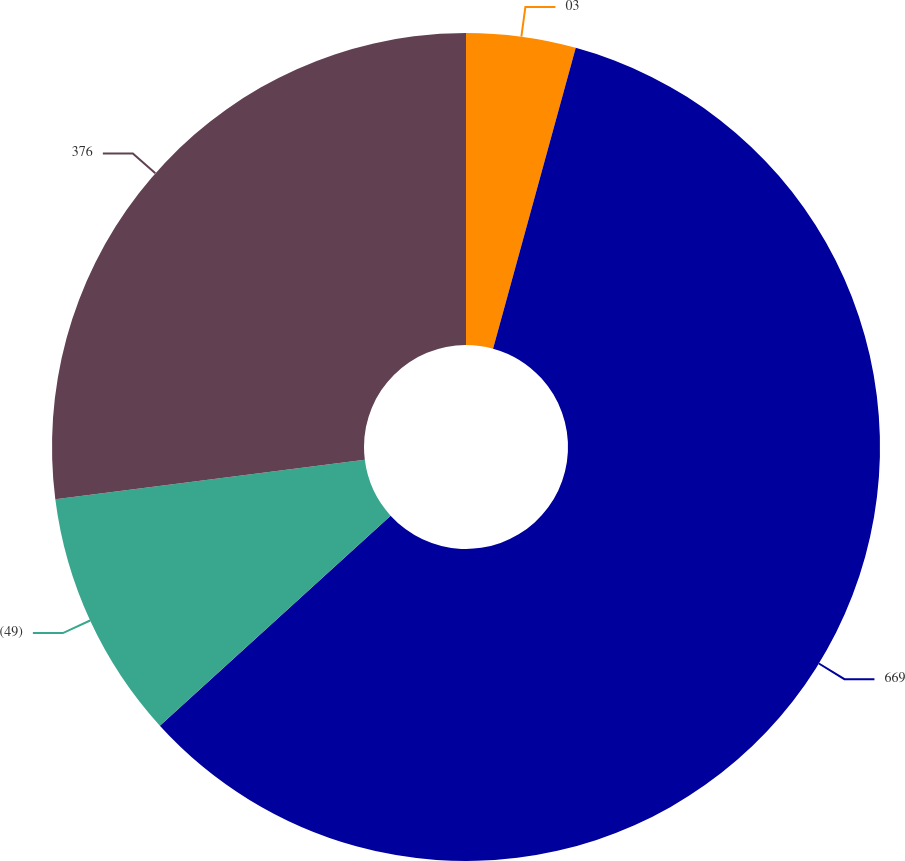Convert chart to OTSL. <chart><loc_0><loc_0><loc_500><loc_500><pie_chart><fcel>03<fcel>669<fcel>(49)<fcel>376<nl><fcel>4.27%<fcel>58.97%<fcel>9.74%<fcel>27.01%<nl></chart> 